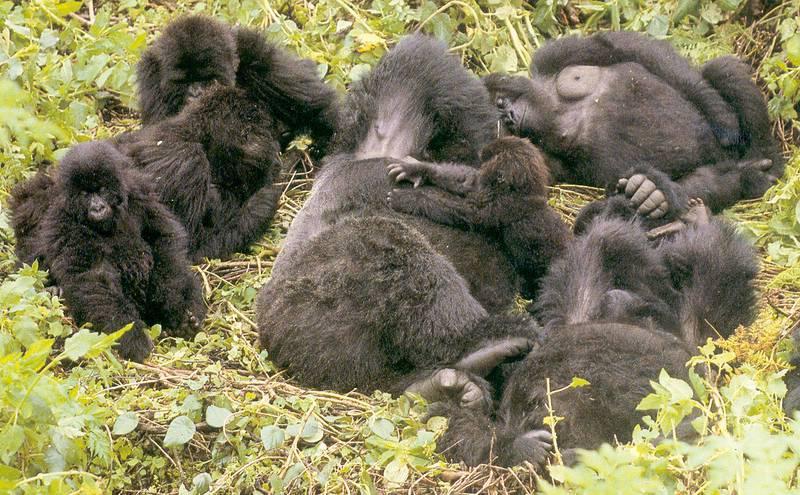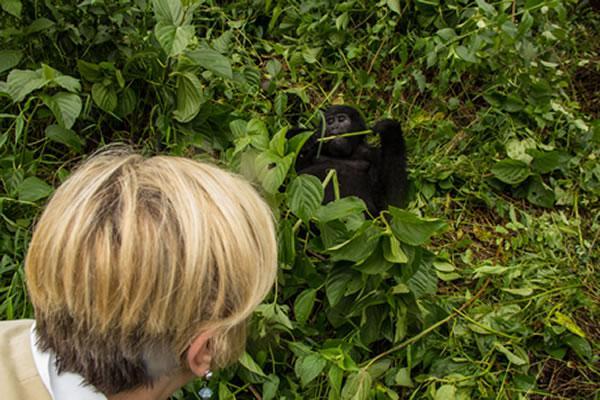The first image is the image on the left, the second image is the image on the right. Considering the images on both sides, is "Each image shows a single gorilla, and all gorillas are in a reclining pose." valid? Answer yes or no. No. The first image is the image on the left, the second image is the image on the right. Given the left and right images, does the statement "There are two gorillas in the pair of images." hold true? Answer yes or no. No. 